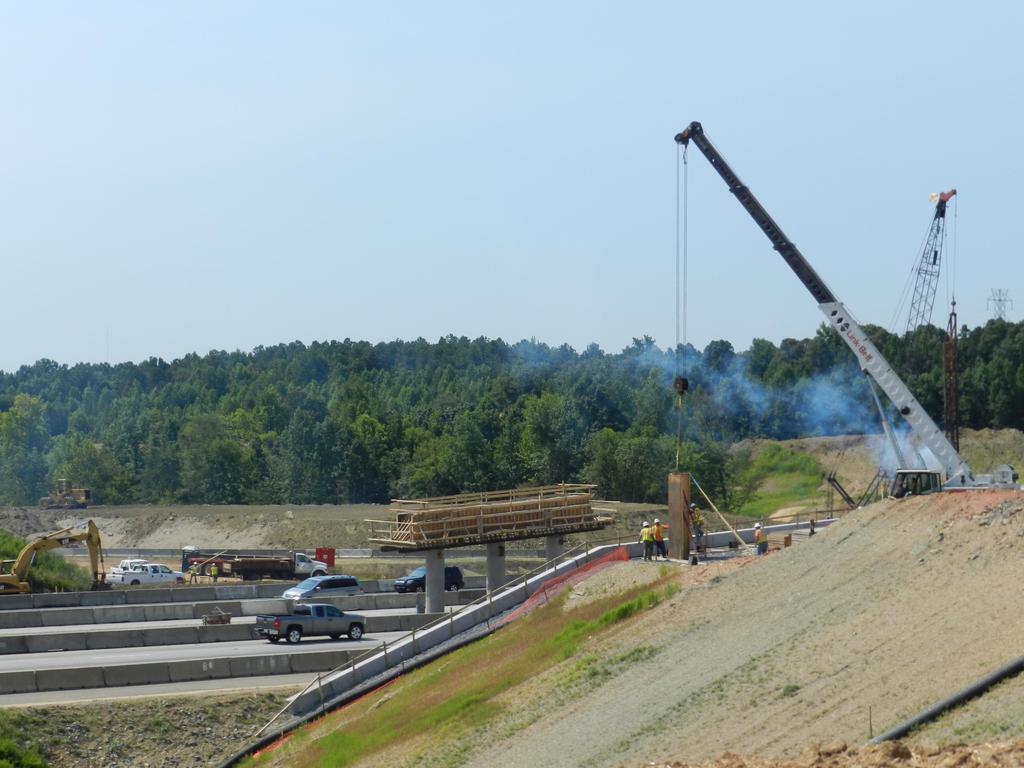Could you give a brief overview of what you see in this image? In this image there are cranes, pillars, roads, vehicles, grass, smoke, people, trees, sky and objects. In the background of the image there are trees and sky. 